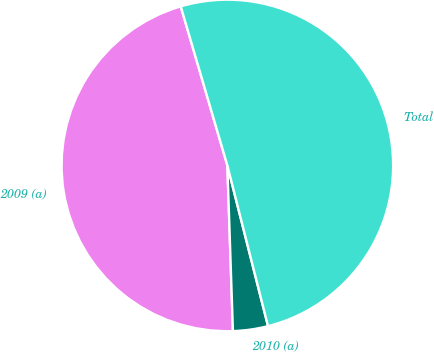Convert chart to OTSL. <chart><loc_0><loc_0><loc_500><loc_500><pie_chart><fcel>2009 (a)<fcel>2010 (a)<fcel>Total<nl><fcel>46.0%<fcel>3.41%<fcel>50.6%<nl></chart> 